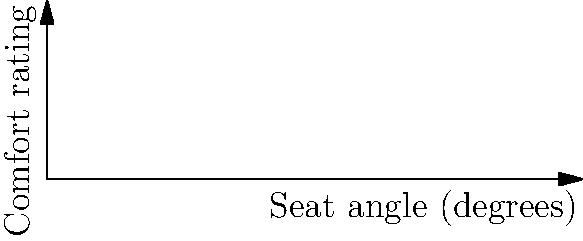In a study on cinema seat ergonomics, researchers found that seat angle significantly impacts viewer comfort. The graph shows comfort ratings for various seat angles. What is the optimal seat angle for maximum viewer comfort, and how might this finding influence avant-garde cinema experiences? To answer this question, we need to analyze the graph and consider its implications for avant-garde cinema:

1. The x-axis represents the seat angle in degrees, while the y-axis shows the comfort rating.

2. The blue curve represents the relationship between seat angle and comfort rating.

3. We can see that the curve rises sharply at first, then peaks, and finally starts to decline.

4. The highest point on the curve, marked with a red dot and labeled "Optimal," represents the maximum comfort rating.

5. This optimal point corresponds to a seat angle of 15 degrees and a comfort rating of 8.5.

6. For avant-garde cinema experiences:
   a) The optimal angle might enhance viewer engagement with unconventional narratives or visual styles.
   b) However, some avant-garde filmmakers might intentionally design uncomfortable seating to challenge viewers' expectations.
   c) The finding could inform the design of flexible seating arrangements for experimental screening spaces.

7. As a skeptical film critic, one might consider how this ergonomic data intersects with artistic intent and viewer experience in non-traditional cinema.
Answer: 15 degrees 